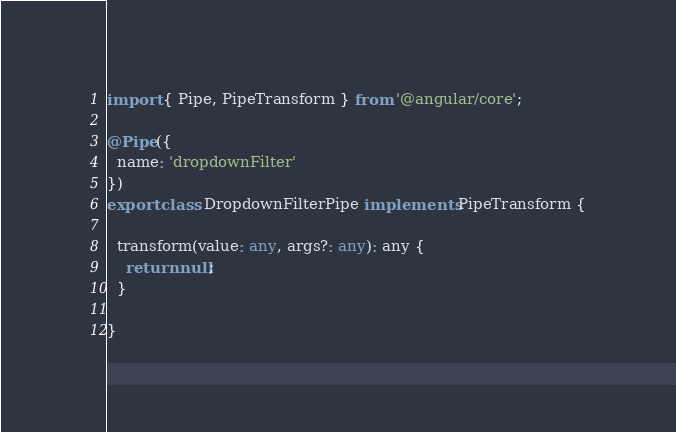Convert code to text. <code><loc_0><loc_0><loc_500><loc_500><_TypeScript_>import { Pipe, PipeTransform } from '@angular/core';

@Pipe({
  name: 'dropdownFilter'
})
export class DropdownFilterPipe implements PipeTransform {

  transform(value: any, args?: any): any {
    return null;
  }

}
</code> 